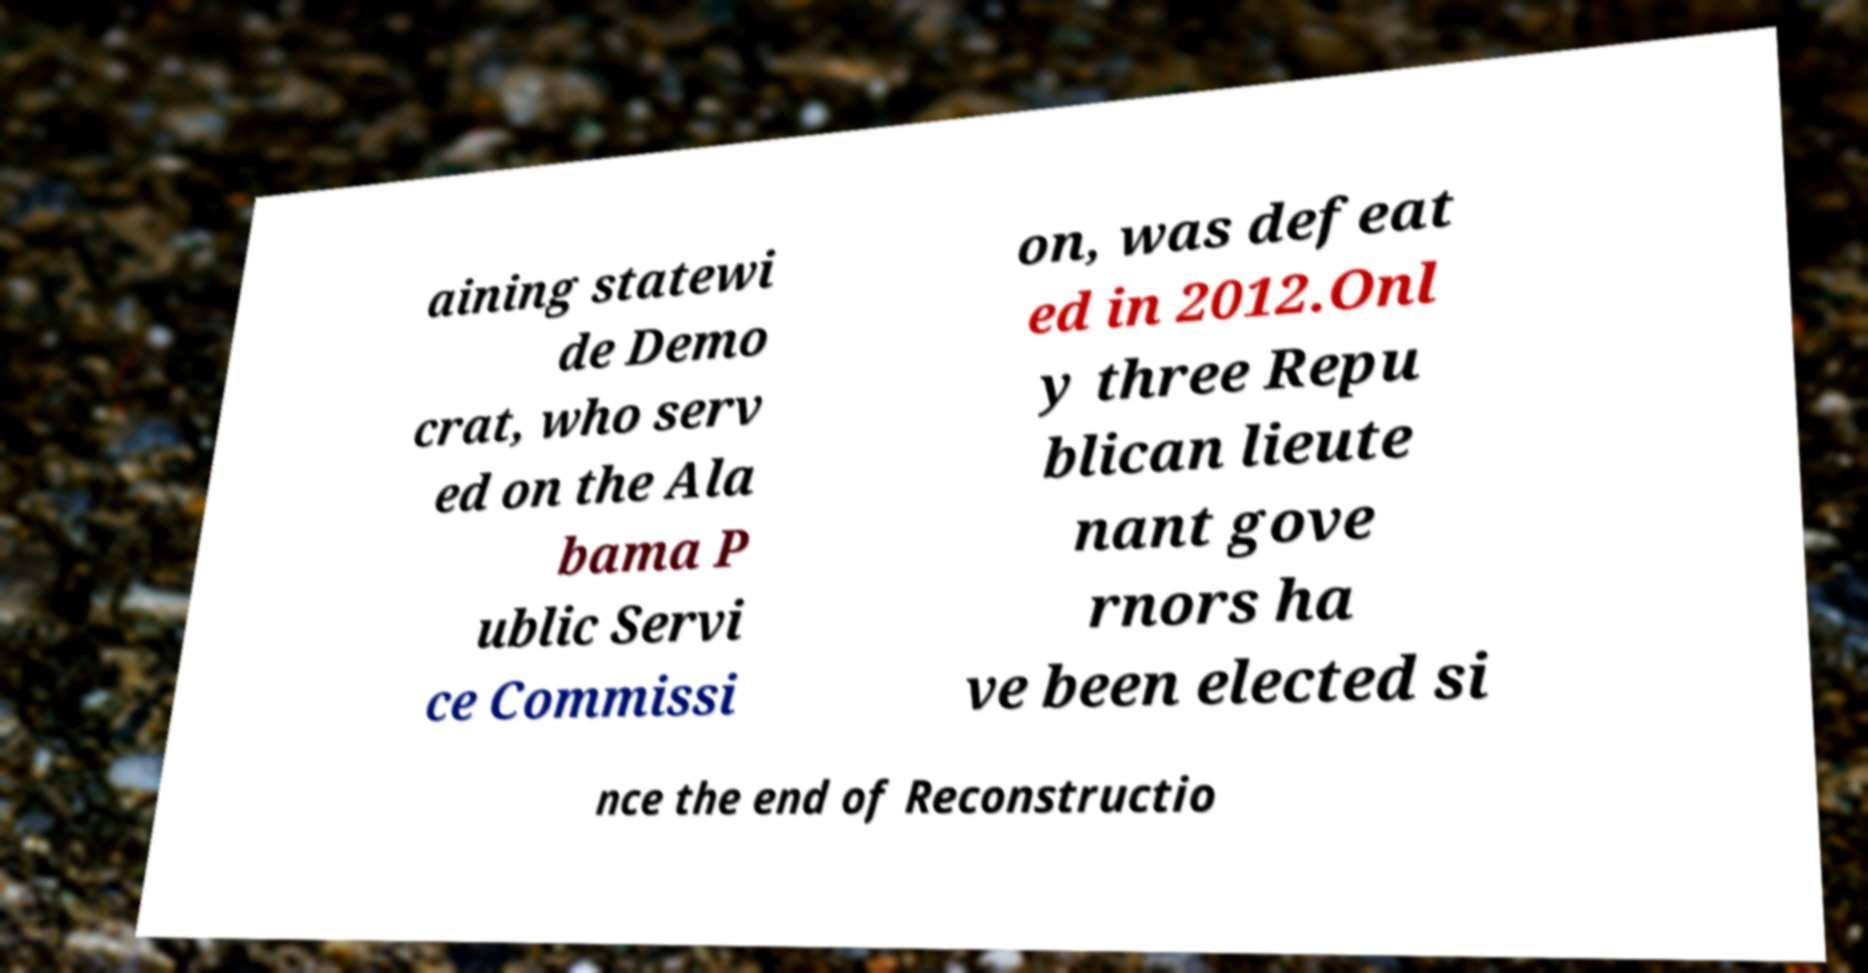For documentation purposes, I need the text within this image transcribed. Could you provide that? aining statewi de Demo crat, who serv ed on the Ala bama P ublic Servi ce Commissi on, was defeat ed in 2012.Onl y three Repu blican lieute nant gove rnors ha ve been elected si nce the end of Reconstructio 